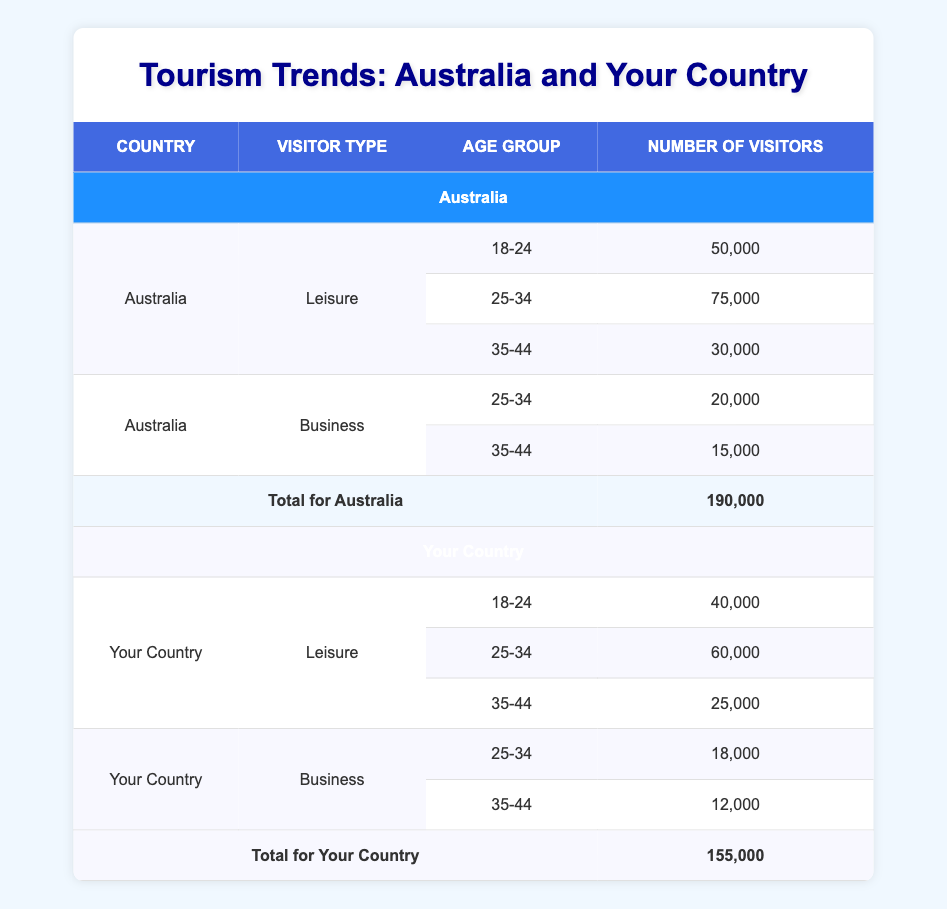What is the total number of visitors from Australia? To find the total number of visitors from Australia, I need to sum the Number of Visitors across all age groups and visitor types. The values are 50000 (18-24 Leisure) + 75000 (25-34 Leisure) + 30000 (35-44 Leisure) + 20000 (25-34 Business) + 15000 (35-44 Business) = 190000.
Answer: 190000 What is the total number of visitors from Your Country? To find the total number of visitors from Your Country, I need to sum the Number of Visitors for all age groups and visitor types. The values are 40000 (18-24 Leisure) + 60000 (25-34 Leisure) + 25000 (35-44 Leisure) + 18000 (25-34 Business) + 12000 (35-44 Business) = 155000.
Answer: 155000 Which visitor type has the highest number of visitors from Australia? Looking at the Number of Visitors by type in Australia, Leisure visitors are 50000 (18-24) + 75000 (25-34) + 30000 (35-44) = 155000, and Business visitors are 20000 (25-34) + 15000 (35-44) = 35000. Therefore, Leisure has the highest number of visitors.
Answer: Leisure Is it true that Your Country has more visitors aged 25-34 for leisure compared to Australia? For Your Country, visitors aged 25-34 for Leisure is 60000, while for Australia it is 75000. Since 60000 is less than 75000, the statement is false.
Answer: No What is the difference in the number of Leisure visitors aged 35-44 between Australia and Your Country? For Australia, the number of Leisure visitors aged 35-44 is 30000, while for Your Country it is 25000. The difference is 30000 - 25000 = 5000.
Answer: 5000 What is the average number of visitors for Leisure aged 18-24 across both countries? The number of visitors aged 18-24 for Leisure in Australia is 50000 and for Your Country it is 40000. To find the average, add them and divide by 2: (50000 + 40000) / 2 = 45000.
Answer: 45000 Which age group has the lowest number of visitors for Business from Your Country? The Business visitor types from Your Country have 18000 (25-34) and 12000 (35-44). Comparing these, 12000 (35-44) is the lowest.
Answer: 35-44 What percentage of the total visitors from Australia are Business visitors? The total visitors from Australia are 190000, and the Business visitors amount to 35000. To find the percentage, (35000 / 190000) * 100 = 18.42 percent.
Answer: 18.42 What is the total number of visitors aged 35-44 from both countries? The number of visitors aged 35-44 is 30000 from Australia and 25000 from Your Country. Summing these gives 30000 + 25000 = 55000.
Answer: 55000 